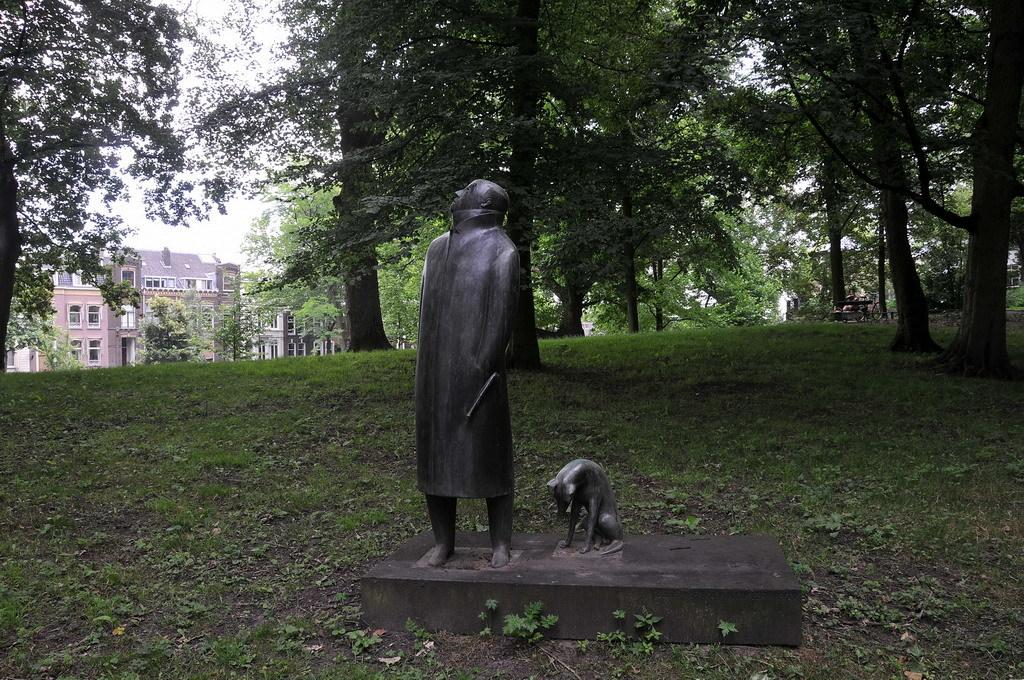What is the main subject in the center of the image? There are statues in the center of the image. What can be seen in the background of the image? There are trees and buildings in the background of the image. What is visible at the bottom of the image? There is ground visible at the bottom of the image. What type of stamp can be seen on the statue in the image? There is no stamp visible on the statues in the image. What riddle is depicted on the statue in the image? There is no riddle depicted on the statues in the image. 